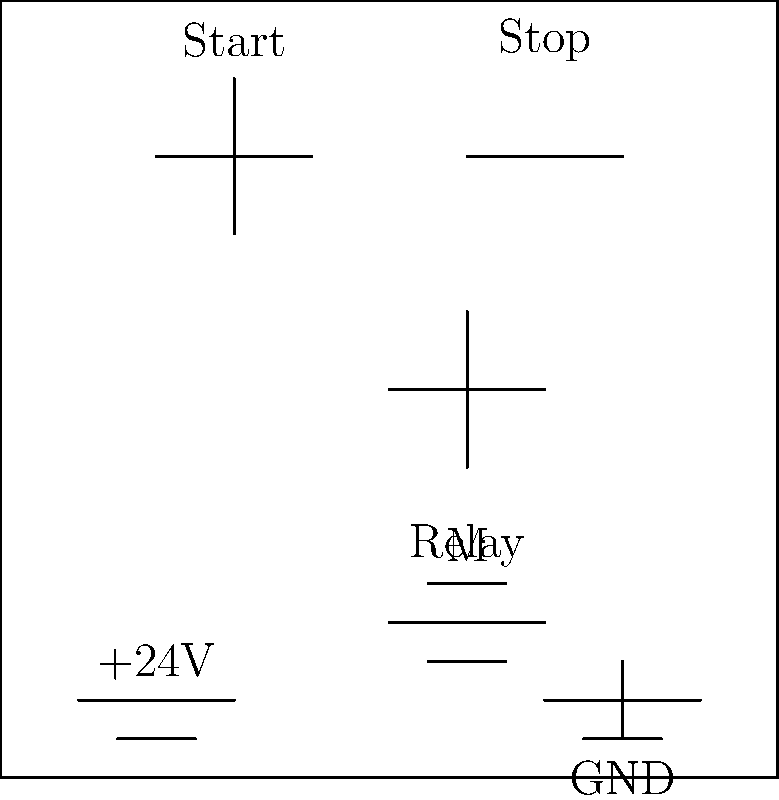In the motor control circuit shown above, what happens when the Start button is pressed and then released? Assume the motor is initially off. To understand the behavior of this motor control circuit, let's analyze it step-by-step:

1. Initial state: The motor is off, and the relay is not energized.

2. When the Start button is pressed:
   a. Current flows from the +24V supply through the Start button and the relay coil to ground.
   b. The relay coil energizes, closing its normally open (NO) contacts.
   c. The NO contacts create a parallel path around the Start button.

3. When the Start button is released:
   a. The parallel path created by the NO contacts maintains current flow through the relay coil.
   b. This is known as a "seal-in" or "latching" circuit.

4. The motor remains on because:
   a. The relay contacts stay closed, providing power to the motor.
   b. The circuit is now in a stable "on" state, independent of the Start button position.

5. To stop the motor:
   a. The Stop button (normally closed) must be pressed to interrupt the current flow.
   b. This de-energizes the relay, opening its contacts and turning off the motor.

This type of circuit is common in industrial control systems, providing a simple way to start and maintain equipment operation with momentary button presses.
Answer: The motor starts and continues running after the Start button is released. 